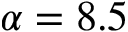Convert formula to latex. <formula><loc_0><loc_0><loc_500><loc_500>\alpha = 8 . 5</formula> 